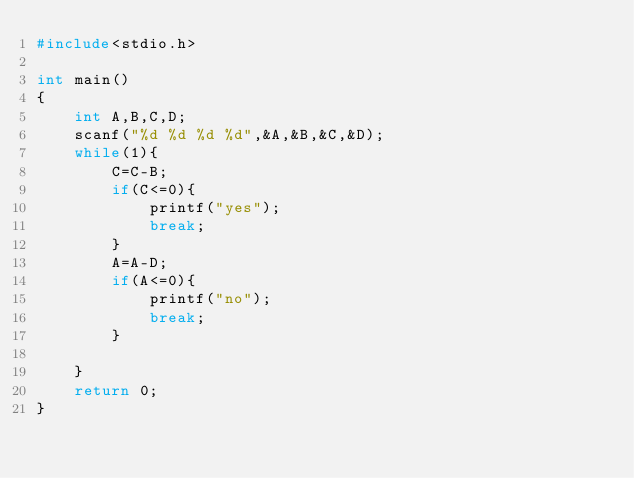<code> <loc_0><loc_0><loc_500><loc_500><_C_>#include<stdio.h>

int main()
{
    int A,B,C,D;
    scanf("%d %d %d %d",&A,&B,&C,&D);
    while(1){
        C=C-B;
        if(C<=0){
            printf("yes");
            break;
        }
        A=A-D;
        if(A<=0){
            printf("no");
            break;
        }

    }
    return 0;
}</code> 